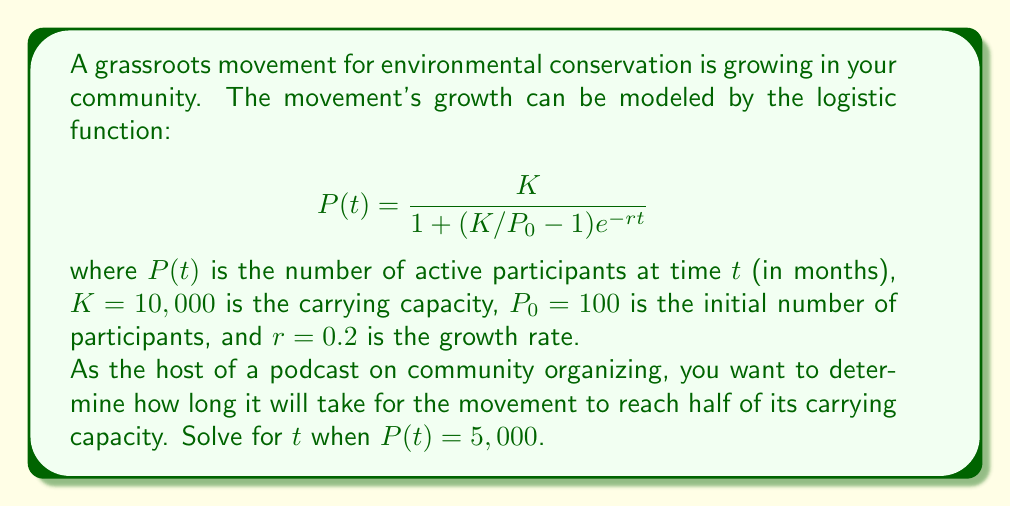Teach me how to tackle this problem. Let's approach this step-by-step:

1) We want to find $t$ when $P(t) = 5,000$. Let's substitute this into our equation:

   $$5,000 = \frac{10,000}{1 + (10,000/100 - 1)e^{-0.2t}}$$

2) Simplify the fraction in the parentheses:

   $$5,000 = \frac{10,000}{1 + 99e^{-0.2t}}$$

3) Divide both sides by 5,000:

   $$1 = \frac{2}{1 + 99e^{-0.2t}}$$

4) Take the reciprocal of both sides:

   $$1 + 99e^{-0.2t} = 2$$

5) Subtract 1 from both sides:

   $$99e^{-0.2t} = 1$$

6) Divide both sides by 99:

   $$e^{-0.2t} = \frac{1}{99}$$

7) Take the natural log of both sides:

   $$-0.2t = \ln(\frac{1}{99}) = -\ln(99)$$

8) Divide both sides by -0.2:

   $$t = \frac{\ln(99)}{0.2}$$

9) Calculate the final value:

   $$t \approx 23.025$$

Therefore, it will take approximately 23.025 months for the movement to reach half of its carrying capacity.
Answer: $23.025$ months 